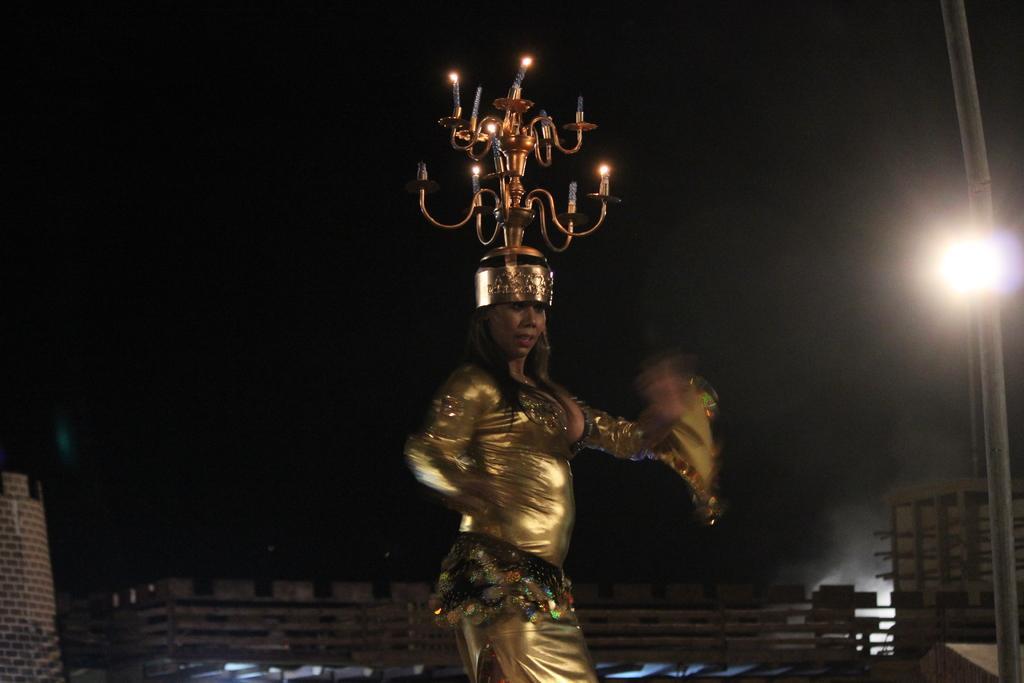Describe this image in one or two sentences. In this image I can see a woman in the front and on her head I can see few candles. I can see she is wearing golden colour dress. In the background I can see a light and a pole on the right side. I can also see this image is little bit in dark. 